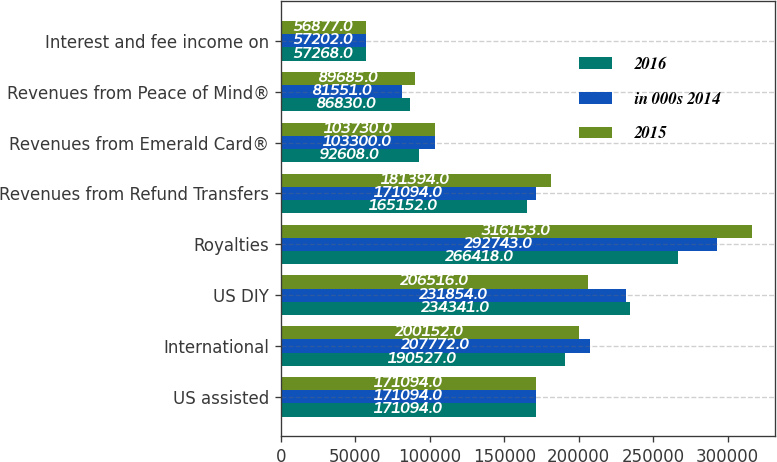Convert chart to OTSL. <chart><loc_0><loc_0><loc_500><loc_500><stacked_bar_chart><ecel><fcel>US assisted<fcel>International<fcel>US DIY<fcel>Royalties<fcel>Revenues from Refund Transfers<fcel>Revenues from Emerald Card®<fcel>Revenues from Peace of Mind®<fcel>Interest and fee income on<nl><fcel>2016<fcel>171094<fcel>190527<fcel>234341<fcel>266418<fcel>165152<fcel>92608<fcel>86830<fcel>57268<nl><fcel>in 000s 2014<fcel>171094<fcel>207772<fcel>231854<fcel>292743<fcel>171094<fcel>103300<fcel>81551<fcel>57202<nl><fcel>2015<fcel>171094<fcel>200152<fcel>206516<fcel>316153<fcel>181394<fcel>103730<fcel>89685<fcel>56877<nl></chart> 